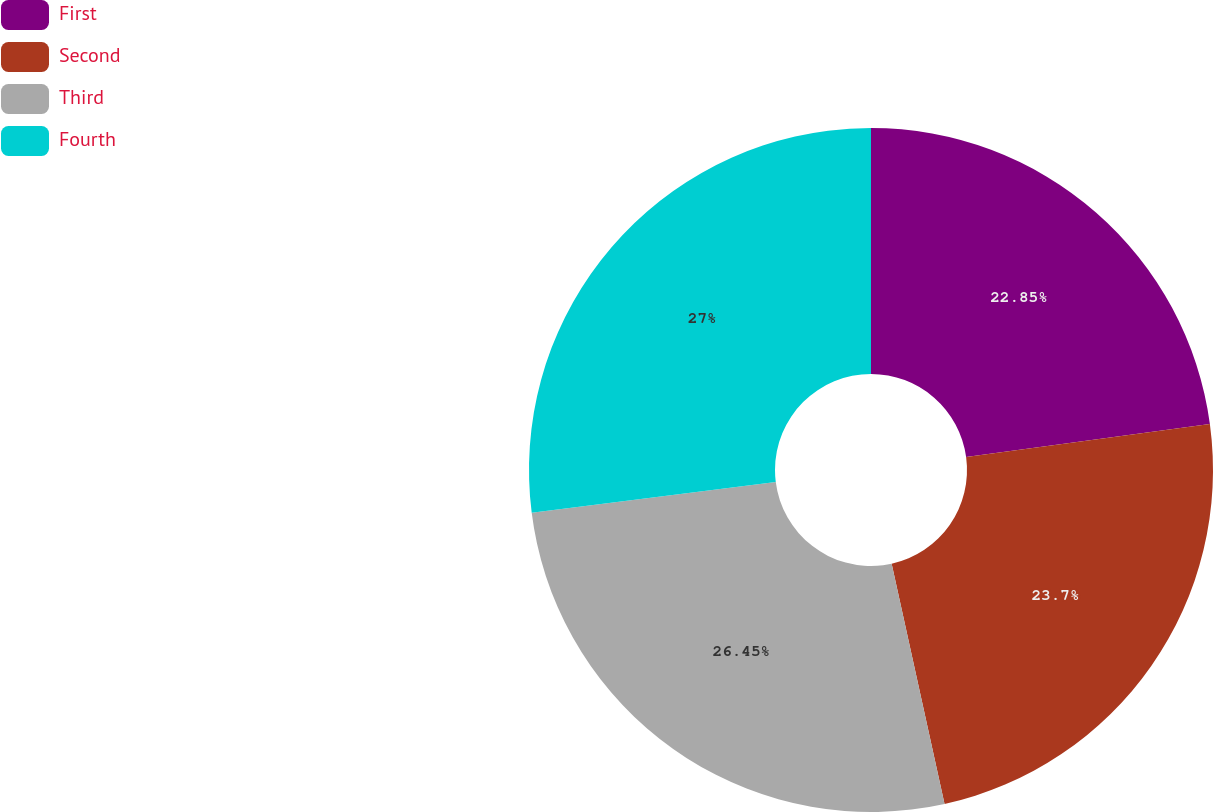Convert chart to OTSL. <chart><loc_0><loc_0><loc_500><loc_500><pie_chart><fcel>First<fcel>Second<fcel>Third<fcel>Fourth<nl><fcel>22.85%<fcel>23.7%<fcel>26.45%<fcel>27.0%<nl></chart> 